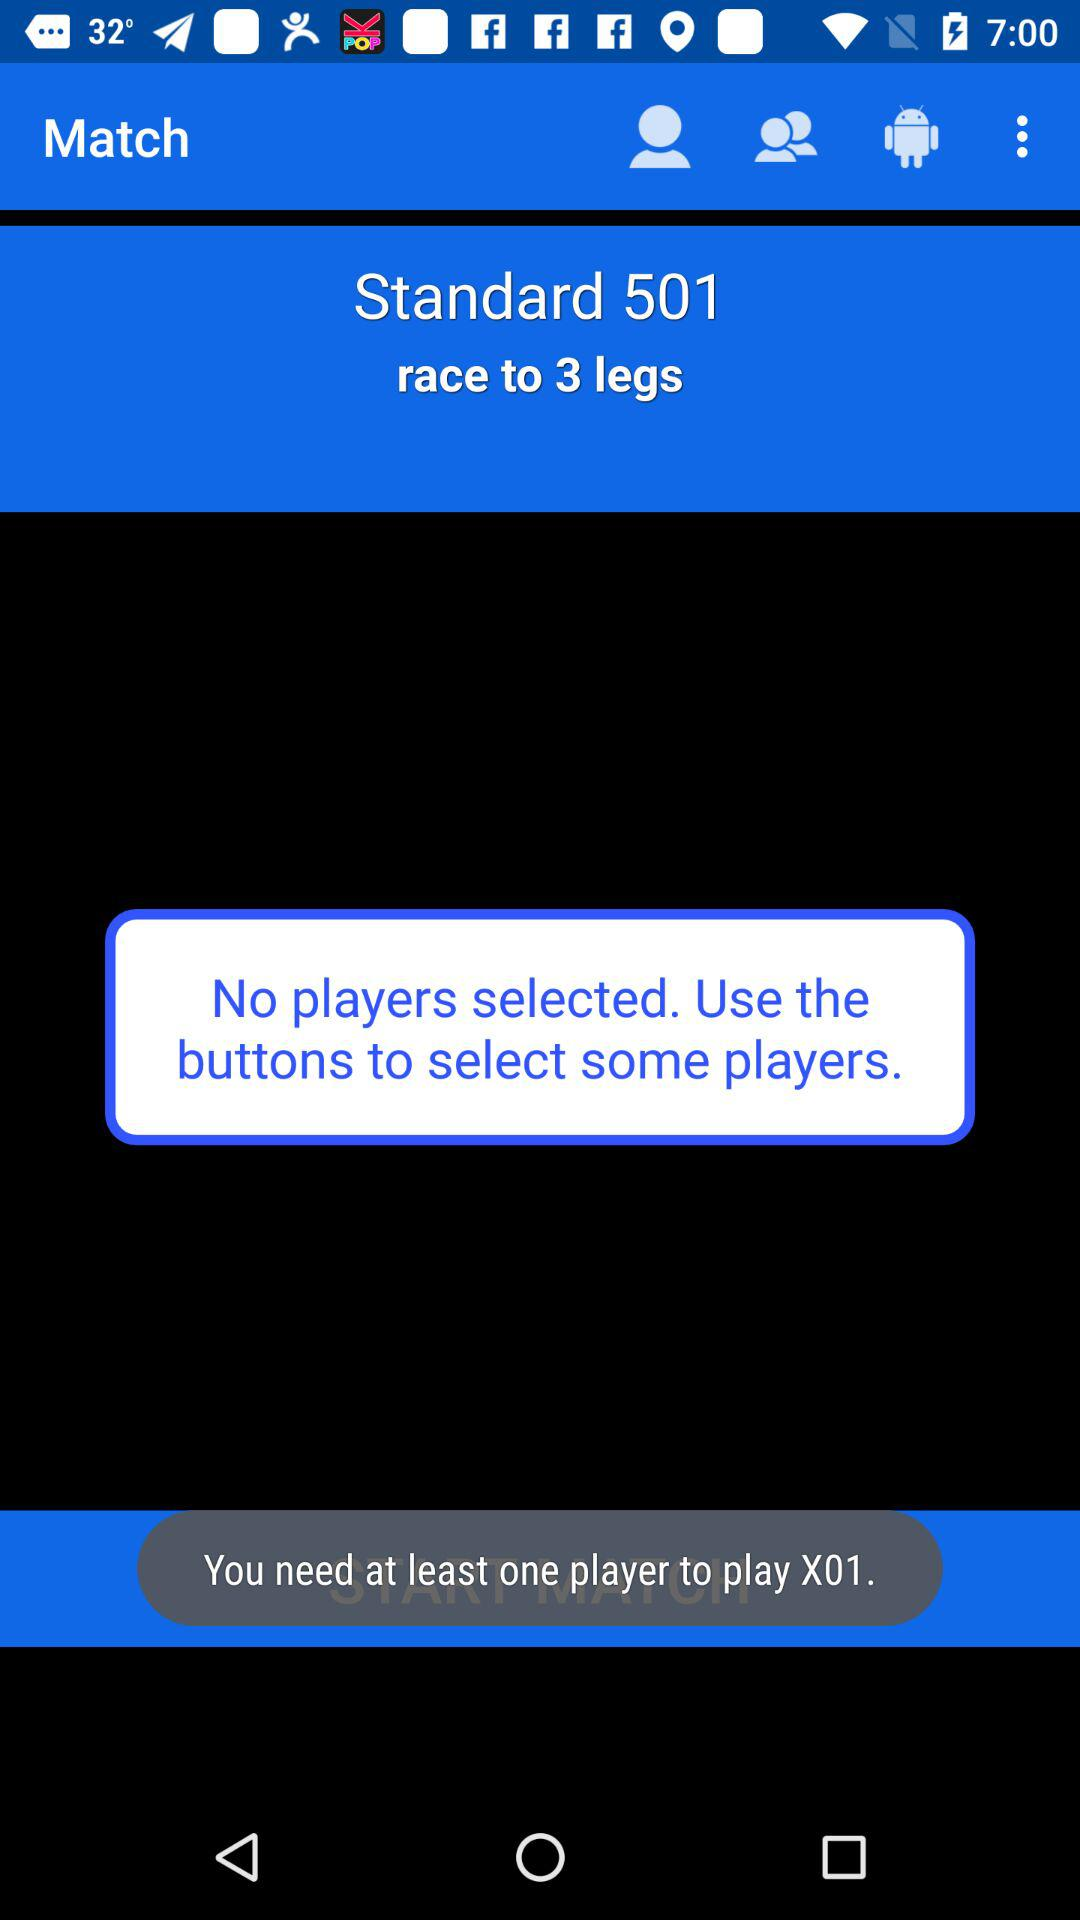How to select the players? You have to use the buttons to select some players. 